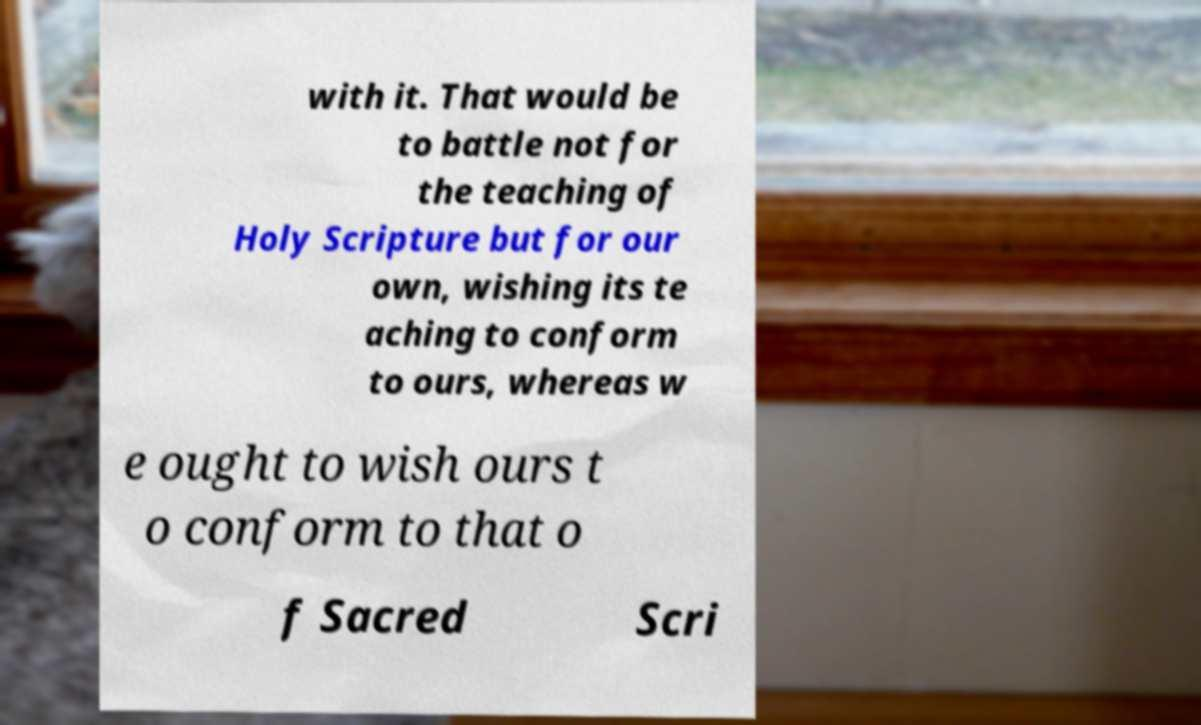Can you accurately transcribe the text from the provided image for me? with it. That would be to battle not for the teaching of Holy Scripture but for our own, wishing its te aching to conform to ours, whereas w e ought to wish ours t o conform to that o f Sacred Scri 